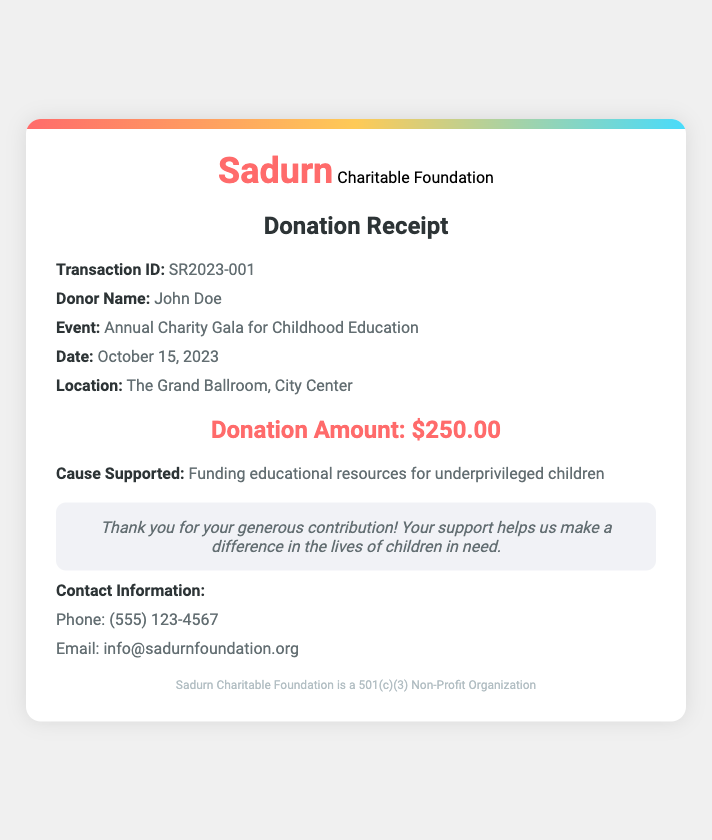What is the transaction ID? The transaction ID is a unique identifier associated with the donation, listed in the details of the receipt.
Answer: SR2023-001 Who is the donor? The donor's name is listed in the details section of the receipt, providing identity for record-keeping.
Answer: John Doe What was the donation amount? The donation amount is explicitly stated in the receipt, representing the financial contribution made to the charity.
Answer: $250.00 When was the donation made? The date is provided in the document to specify when the donation took place, ensuring clarity for financial records.
Answer: October 15, 2023 What event was the donation associated with? The event name is mentioned to highlight the specific charity initiative linked to the donation made.
Answer: Annual Charity Gala for Childhood Education What cause does the donation support? The cause supported is detailed in the document, explaining the purpose of the donation and where the funds will be utilized.
Answer: Funding educational resources for underprivileged children What is the location of the event? The location is provided to indicate where the charity event took place, which may be important for attendees and donors alike.
Answer: The Grand Ballroom, City Center What type of organization is Sadurn Charitable Foundation? The type of organization is indicated in the footer to establish the foundation's legal status and credibility.
Answer: 501(c)(3) Non-Profit Organization What is the contact phone number for the foundation? The contact phone number is listed for donors or interested parties to reach out with inquiries or support-related questions.
Answer: (555) 123-4567 